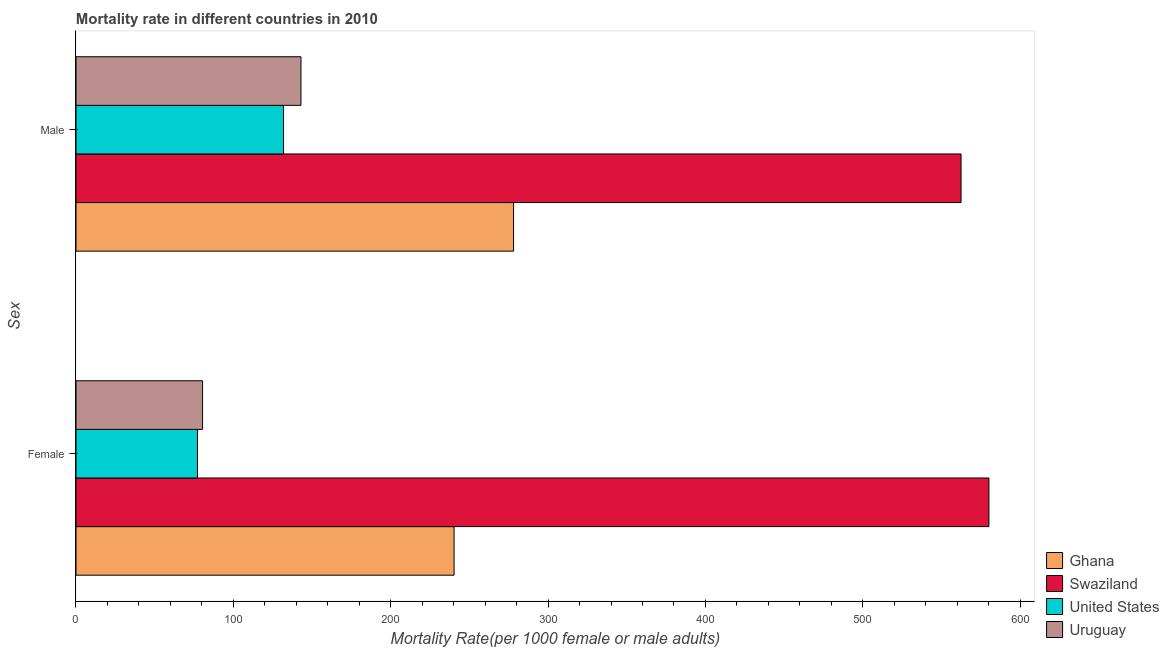How many groups of bars are there?
Ensure brevity in your answer.  2. How many bars are there on the 1st tick from the bottom?
Offer a terse response. 4. What is the male mortality rate in Ghana?
Offer a very short reply. 278.05. Across all countries, what is the maximum female mortality rate?
Your response must be concise. 580.13. Across all countries, what is the minimum male mortality rate?
Provide a short and direct response. 131.9. In which country was the male mortality rate maximum?
Keep it short and to the point. Swaziland. In which country was the male mortality rate minimum?
Your answer should be very brief. United States. What is the total male mortality rate in the graph?
Your answer should be very brief. 1115.33. What is the difference between the female mortality rate in United States and that in Swaziland?
Offer a terse response. -502.94. What is the difference between the male mortality rate in Ghana and the female mortality rate in United States?
Your answer should be compact. 200.86. What is the average female mortality rate per country?
Your response must be concise. 244.5. What is the difference between the male mortality rate and female mortality rate in Uruguay?
Your answer should be compact. 62.52. In how many countries, is the female mortality rate greater than 580 ?
Your answer should be very brief. 1. What is the ratio of the male mortality rate in Uruguay to that in Swaziland?
Make the answer very short. 0.25. Is the female mortality rate in Ghana less than that in Uruguay?
Your answer should be very brief. No. What does the 4th bar from the top in Male represents?
Give a very brief answer. Ghana. What does the 2nd bar from the bottom in Female represents?
Offer a terse response. Swaziland. How many countries are there in the graph?
Ensure brevity in your answer.  4. Are the values on the major ticks of X-axis written in scientific E-notation?
Give a very brief answer. No. Does the graph contain any zero values?
Offer a terse response. No. Does the graph contain grids?
Give a very brief answer. No. What is the title of the graph?
Your response must be concise. Mortality rate in different countries in 2010. Does "Qatar" appear as one of the legend labels in the graph?
Your response must be concise. No. What is the label or title of the X-axis?
Offer a terse response. Mortality Rate(per 1000 female or male adults). What is the label or title of the Y-axis?
Keep it short and to the point. Sex. What is the Mortality Rate(per 1000 female or male adults) in Ghana in Female?
Provide a short and direct response. 240.26. What is the Mortality Rate(per 1000 female or male adults) in Swaziland in Female?
Offer a terse response. 580.13. What is the Mortality Rate(per 1000 female or male adults) in United States in Female?
Provide a short and direct response. 77.19. What is the Mortality Rate(per 1000 female or male adults) of Uruguay in Female?
Offer a very short reply. 80.44. What is the Mortality Rate(per 1000 female or male adults) of Ghana in Male?
Make the answer very short. 278.05. What is the Mortality Rate(per 1000 female or male adults) of Swaziland in Male?
Your answer should be very brief. 562.41. What is the Mortality Rate(per 1000 female or male adults) in United States in Male?
Provide a short and direct response. 131.9. What is the Mortality Rate(per 1000 female or male adults) of Uruguay in Male?
Keep it short and to the point. 142.96. Across all Sex, what is the maximum Mortality Rate(per 1000 female or male adults) in Ghana?
Offer a very short reply. 278.05. Across all Sex, what is the maximum Mortality Rate(per 1000 female or male adults) of Swaziland?
Offer a very short reply. 580.13. Across all Sex, what is the maximum Mortality Rate(per 1000 female or male adults) in United States?
Keep it short and to the point. 131.9. Across all Sex, what is the maximum Mortality Rate(per 1000 female or male adults) of Uruguay?
Your answer should be very brief. 142.96. Across all Sex, what is the minimum Mortality Rate(per 1000 female or male adults) in Ghana?
Your answer should be compact. 240.26. Across all Sex, what is the minimum Mortality Rate(per 1000 female or male adults) of Swaziland?
Provide a succinct answer. 562.41. Across all Sex, what is the minimum Mortality Rate(per 1000 female or male adults) in United States?
Make the answer very short. 77.19. Across all Sex, what is the minimum Mortality Rate(per 1000 female or male adults) in Uruguay?
Offer a terse response. 80.44. What is the total Mortality Rate(per 1000 female or male adults) of Ghana in the graph?
Make the answer very short. 518.31. What is the total Mortality Rate(per 1000 female or male adults) of Swaziland in the graph?
Ensure brevity in your answer.  1142.54. What is the total Mortality Rate(per 1000 female or male adults) of United States in the graph?
Provide a short and direct response. 209.09. What is the total Mortality Rate(per 1000 female or male adults) in Uruguay in the graph?
Offer a very short reply. 223.41. What is the difference between the Mortality Rate(per 1000 female or male adults) of Ghana in Female and that in Male?
Provide a short and direct response. -37.8. What is the difference between the Mortality Rate(per 1000 female or male adults) of Swaziland in Female and that in Male?
Your response must be concise. 17.71. What is the difference between the Mortality Rate(per 1000 female or male adults) in United States in Female and that in Male?
Give a very brief answer. -54.72. What is the difference between the Mortality Rate(per 1000 female or male adults) of Uruguay in Female and that in Male?
Provide a short and direct response. -62.52. What is the difference between the Mortality Rate(per 1000 female or male adults) in Ghana in Female and the Mortality Rate(per 1000 female or male adults) in Swaziland in Male?
Make the answer very short. -322.16. What is the difference between the Mortality Rate(per 1000 female or male adults) of Ghana in Female and the Mortality Rate(per 1000 female or male adults) of United States in Male?
Ensure brevity in your answer.  108.35. What is the difference between the Mortality Rate(per 1000 female or male adults) of Ghana in Female and the Mortality Rate(per 1000 female or male adults) of Uruguay in Male?
Ensure brevity in your answer.  97.29. What is the difference between the Mortality Rate(per 1000 female or male adults) in Swaziland in Female and the Mortality Rate(per 1000 female or male adults) in United States in Male?
Provide a succinct answer. 448.23. What is the difference between the Mortality Rate(per 1000 female or male adults) of Swaziland in Female and the Mortality Rate(per 1000 female or male adults) of Uruguay in Male?
Your response must be concise. 437.16. What is the difference between the Mortality Rate(per 1000 female or male adults) of United States in Female and the Mortality Rate(per 1000 female or male adults) of Uruguay in Male?
Offer a terse response. -65.78. What is the average Mortality Rate(per 1000 female or male adults) in Ghana per Sex?
Your answer should be compact. 259.15. What is the average Mortality Rate(per 1000 female or male adults) of Swaziland per Sex?
Make the answer very short. 571.27. What is the average Mortality Rate(per 1000 female or male adults) of United States per Sex?
Keep it short and to the point. 104.54. What is the average Mortality Rate(per 1000 female or male adults) in Uruguay per Sex?
Offer a terse response. 111.7. What is the difference between the Mortality Rate(per 1000 female or male adults) in Ghana and Mortality Rate(per 1000 female or male adults) in Swaziland in Female?
Offer a very short reply. -339.87. What is the difference between the Mortality Rate(per 1000 female or male adults) in Ghana and Mortality Rate(per 1000 female or male adults) in United States in Female?
Provide a succinct answer. 163.07. What is the difference between the Mortality Rate(per 1000 female or male adults) in Ghana and Mortality Rate(per 1000 female or male adults) in Uruguay in Female?
Provide a short and direct response. 159.81. What is the difference between the Mortality Rate(per 1000 female or male adults) of Swaziland and Mortality Rate(per 1000 female or male adults) of United States in Female?
Your answer should be very brief. 502.94. What is the difference between the Mortality Rate(per 1000 female or male adults) in Swaziland and Mortality Rate(per 1000 female or male adults) in Uruguay in Female?
Offer a terse response. 499.68. What is the difference between the Mortality Rate(per 1000 female or male adults) of United States and Mortality Rate(per 1000 female or male adults) of Uruguay in Female?
Offer a very short reply. -3.26. What is the difference between the Mortality Rate(per 1000 female or male adults) of Ghana and Mortality Rate(per 1000 female or male adults) of Swaziland in Male?
Offer a terse response. -284.36. What is the difference between the Mortality Rate(per 1000 female or male adults) in Ghana and Mortality Rate(per 1000 female or male adults) in United States in Male?
Your response must be concise. 146.15. What is the difference between the Mortality Rate(per 1000 female or male adults) in Ghana and Mortality Rate(per 1000 female or male adults) in Uruguay in Male?
Provide a succinct answer. 135.09. What is the difference between the Mortality Rate(per 1000 female or male adults) in Swaziland and Mortality Rate(per 1000 female or male adults) in United States in Male?
Provide a succinct answer. 430.51. What is the difference between the Mortality Rate(per 1000 female or male adults) of Swaziland and Mortality Rate(per 1000 female or male adults) of Uruguay in Male?
Ensure brevity in your answer.  419.45. What is the difference between the Mortality Rate(per 1000 female or male adults) in United States and Mortality Rate(per 1000 female or male adults) in Uruguay in Male?
Give a very brief answer. -11.06. What is the ratio of the Mortality Rate(per 1000 female or male adults) of Ghana in Female to that in Male?
Ensure brevity in your answer.  0.86. What is the ratio of the Mortality Rate(per 1000 female or male adults) in Swaziland in Female to that in Male?
Your answer should be compact. 1.03. What is the ratio of the Mortality Rate(per 1000 female or male adults) of United States in Female to that in Male?
Offer a terse response. 0.59. What is the ratio of the Mortality Rate(per 1000 female or male adults) in Uruguay in Female to that in Male?
Your answer should be compact. 0.56. What is the difference between the highest and the second highest Mortality Rate(per 1000 female or male adults) of Ghana?
Make the answer very short. 37.8. What is the difference between the highest and the second highest Mortality Rate(per 1000 female or male adults) in Swaziland?
Make the answer very short. 17.71. What is the difference between the highest and the second highest Mortality Rate(per 1000 female or male adults) of United States?
Keep it short and to the point. 54.72. What is the difference between the highest and the second highest Mortality Rate(per 1000 female or male adults) of Uruguay?
Provide a succinct answer. 62.52. What is the difference between the highest and the lowest Mortality Rate(per 1000 female or male adults) in Ghana?
Make the answer very short. 37.8. What is the difference between the highest and the lowest Mortality Rate(per 1000 female or male adults) in Swaziland?
Your response must be concise. 17.71. What is the difference between the highest and the lowest Mortality Rate(per 1000 female or male adults) of United States?
Offer a terse response. 54.72. What is the difference between the highest and the lowest Mortality Rate(per 1000 female or male adults) in Uruguay?
Your response must be concise. 62.52. 